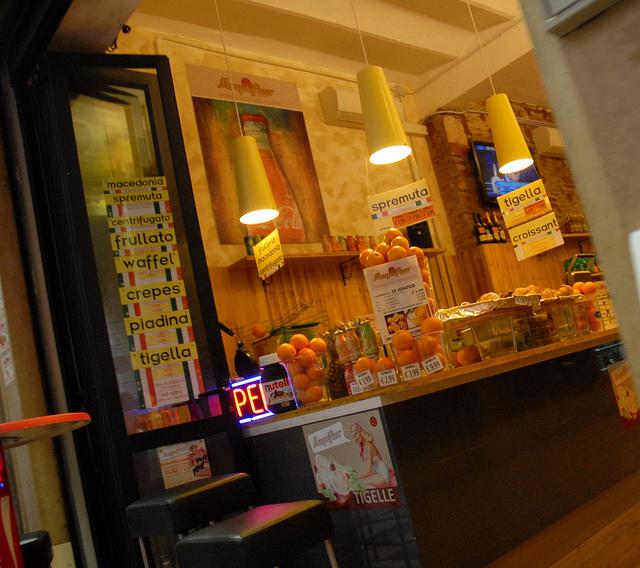What would happen if you ate a large amount of this kind of food for a long time?
Answer briefly. Nothing. How many street light are shown?
Give a very brief answer. 0. What is all the way on the left?
Short answer required. Table. What does the sign say on the restaurant?
Give a very brief answer. Open. Would someone that only speaks English shop here?
Quick response, please. No. How many different types of fruits are there?
Short answer required. 1. Was this picture taken in Italy?
Be succinct. Yes. What does this company sell?
Give a very brief answer. Fruit. 